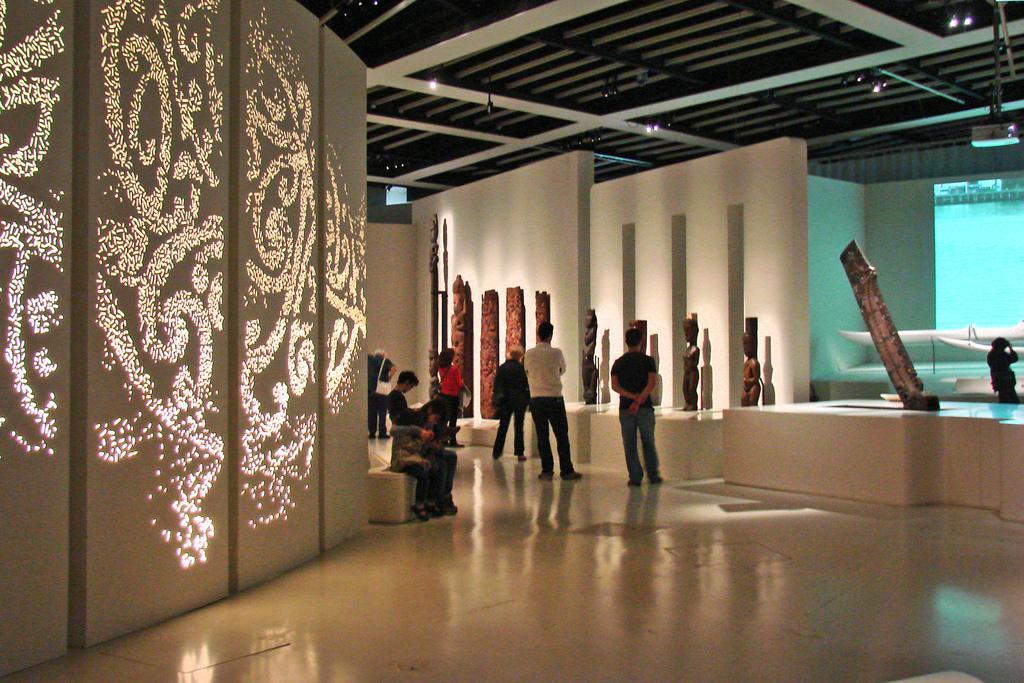Could you give a brief overview of what you see in this image? In the image there are few persons standing and sitting in the back staring at the idols in front of the wall, on the left side there is a wall with a design on it, this seems to be in a museum. 